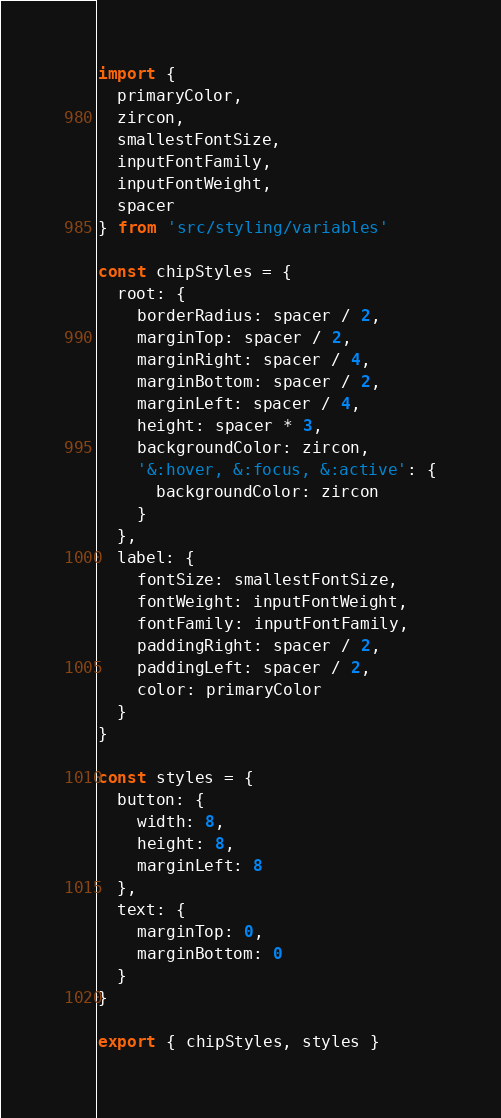Convert code to text. <code><loc_0><loc_0><loc_500><loc_500><_JavaScript_>import {
  primaryColor,
  zircon,
  smallestFontSize,
  inputFontFamily,
  inputFontWeight,
  spacer
} from 'src/styling/variables'

const chipStyles = {
  root: {
    borderRadius: spacer / 2,
    marginTop: spacer / 2,
    marginRight: spacer / 4,
    marginBottom: spacer / 2,
    marginLeft: spacer / 4,
    height: spacer * 3,
    backgroundColor: zircon,
    '&:hover, &:focus, &:active': {
      backgroundColor: zircon
    }
  },
  label: {
    fontSize: smallestFontSize,
    fontWeight: inputFontWeight,
    fontFamily: inputFontFamily,
    paddingRight: spacer / 2,
    paddingLeft: spacer / 2,
    color: primaryColor
  }
}

const styles = {
  button: {
    width: 8,
    height: 8,
    marginLeft: 8
  },
  text: {
    marginTop: 0,
    marginBottom: 0
  }
}

export { chipStyles, styles }
</code> 